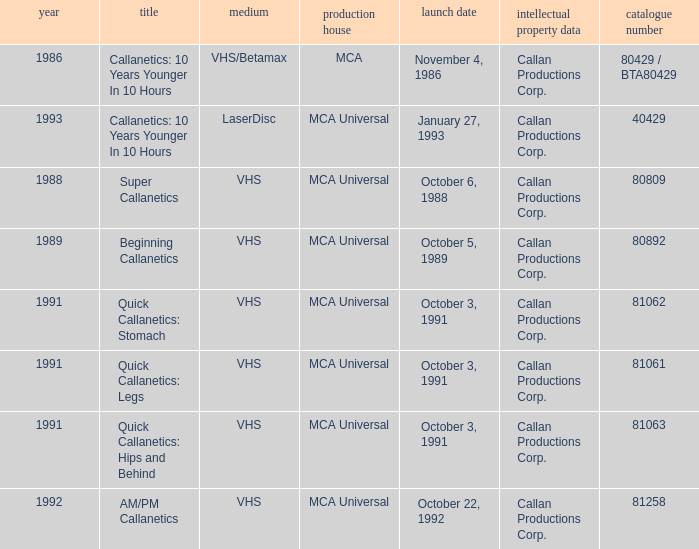Name the studio for catalog number 81063 MCA Universal. 